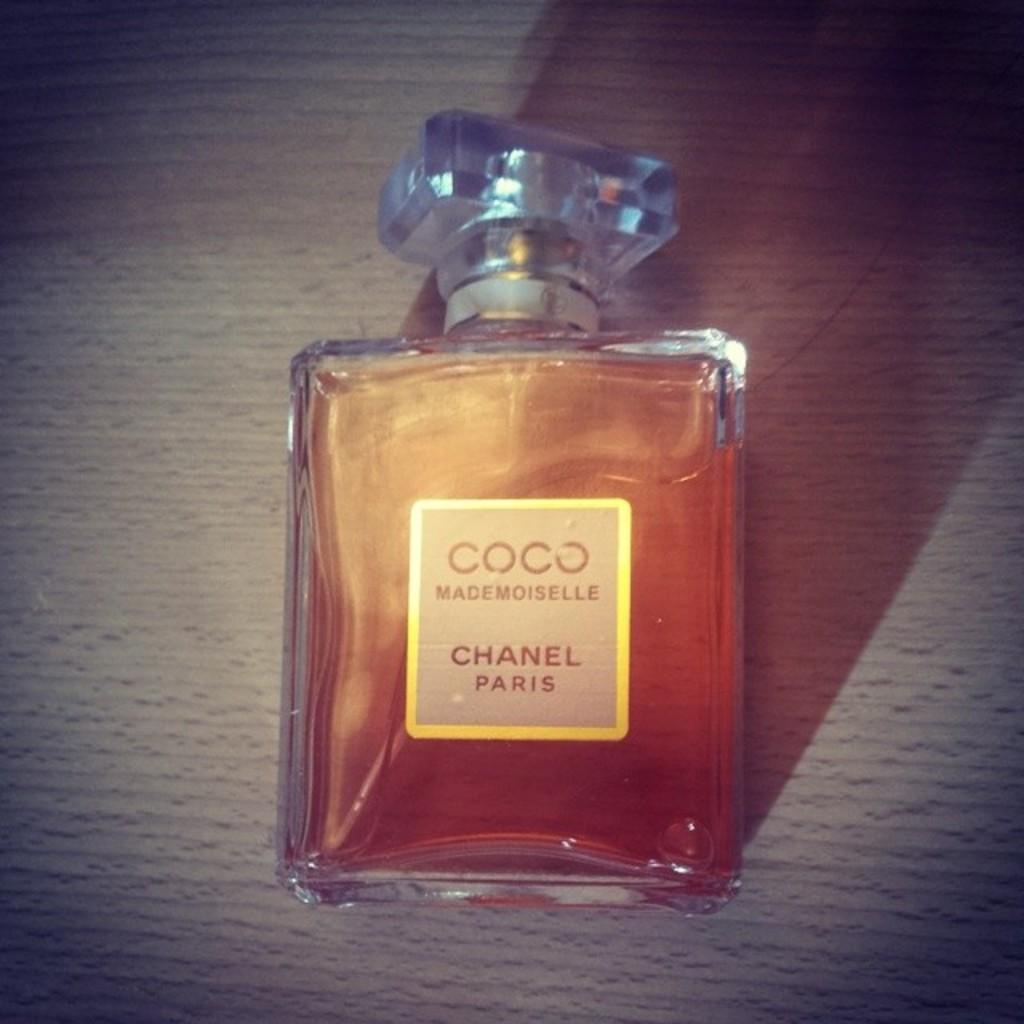<image>
Present a compact description of the photo's key features. Brown bottle of Coco Mademoiselle on top of a surface. 